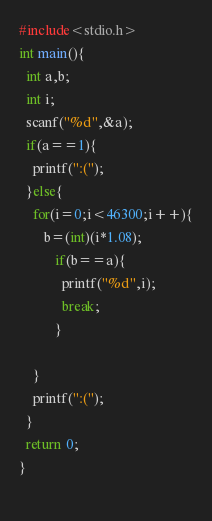Convert code to text. <code><loc_0><loc_0><loc_500><loc_500><_C_>#include<stdio.h>
int main(){
  int a,b;
  int i;
  scanf("%d",&a);
  if(a==1){
    printf(":(");
  }else{
    for(i=0;i<46300;i++){
       b=(int)(i*1.08);
          if(b==a){
            printf("%d",i);
            break;
          }
      
    }
    printf(":(");
  }
  return 0;
}
  
</code> 